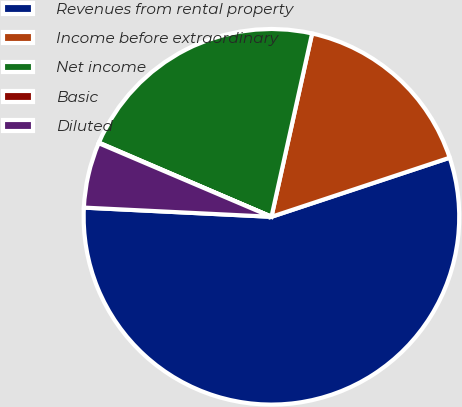Convert chart to OTSL. <chart><loc_0><loc_0><loc_500><loc_500><pie_chart><fcel>Revenues from rental property<fcel>Income before extraordinary<fcel>Net income<fcel>Basic<fcel>Diluted<nl><fcel>55.87%<fcel>16.43%<fcel>22.01%<fcel>0.05%<fcel>5.63%<nl></chart> 